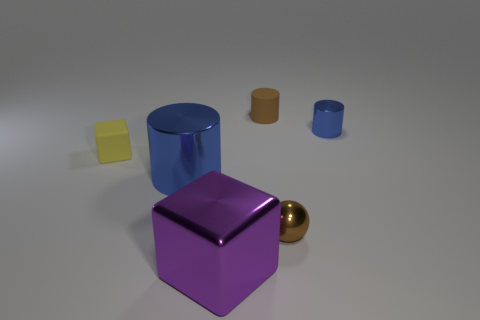Can you describe the texture of the purple object in front? The purple object in front appears to have a smooth and reflective surface, which could be indicative of a metallic or plastic material. What might the function of these objects be? These objects may serve educational or illustrative purposes, perhaps used to teach about geometry, colors, and materials, or simply as decorative items. 